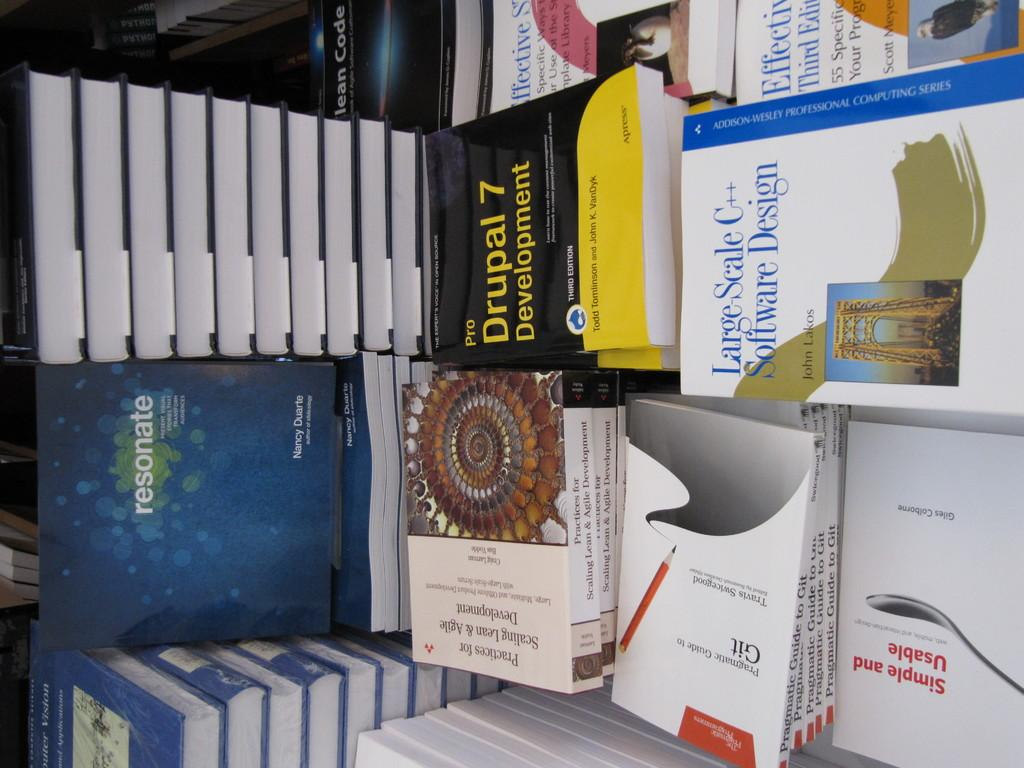<image>
Write a terse but informative summary of the picture. Black and yellow book titled "Pro Drupal 7 Development" next to some other white books. 